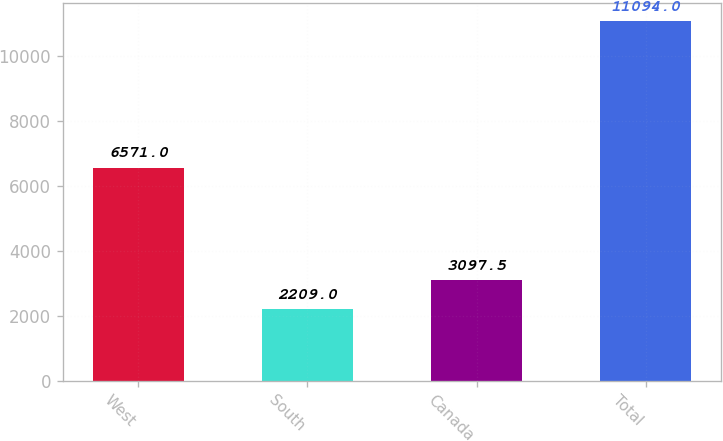Convert chart to OTSL. <chart><loc_0><loc_0><loc_500><loc_500><bar_chart><fcel>West<fcel>South<fcel>Canada<fcel>Total<nl><fcel>6571<fcel>2209<fcel>3097.5<fcel>11094<nl></chart> 